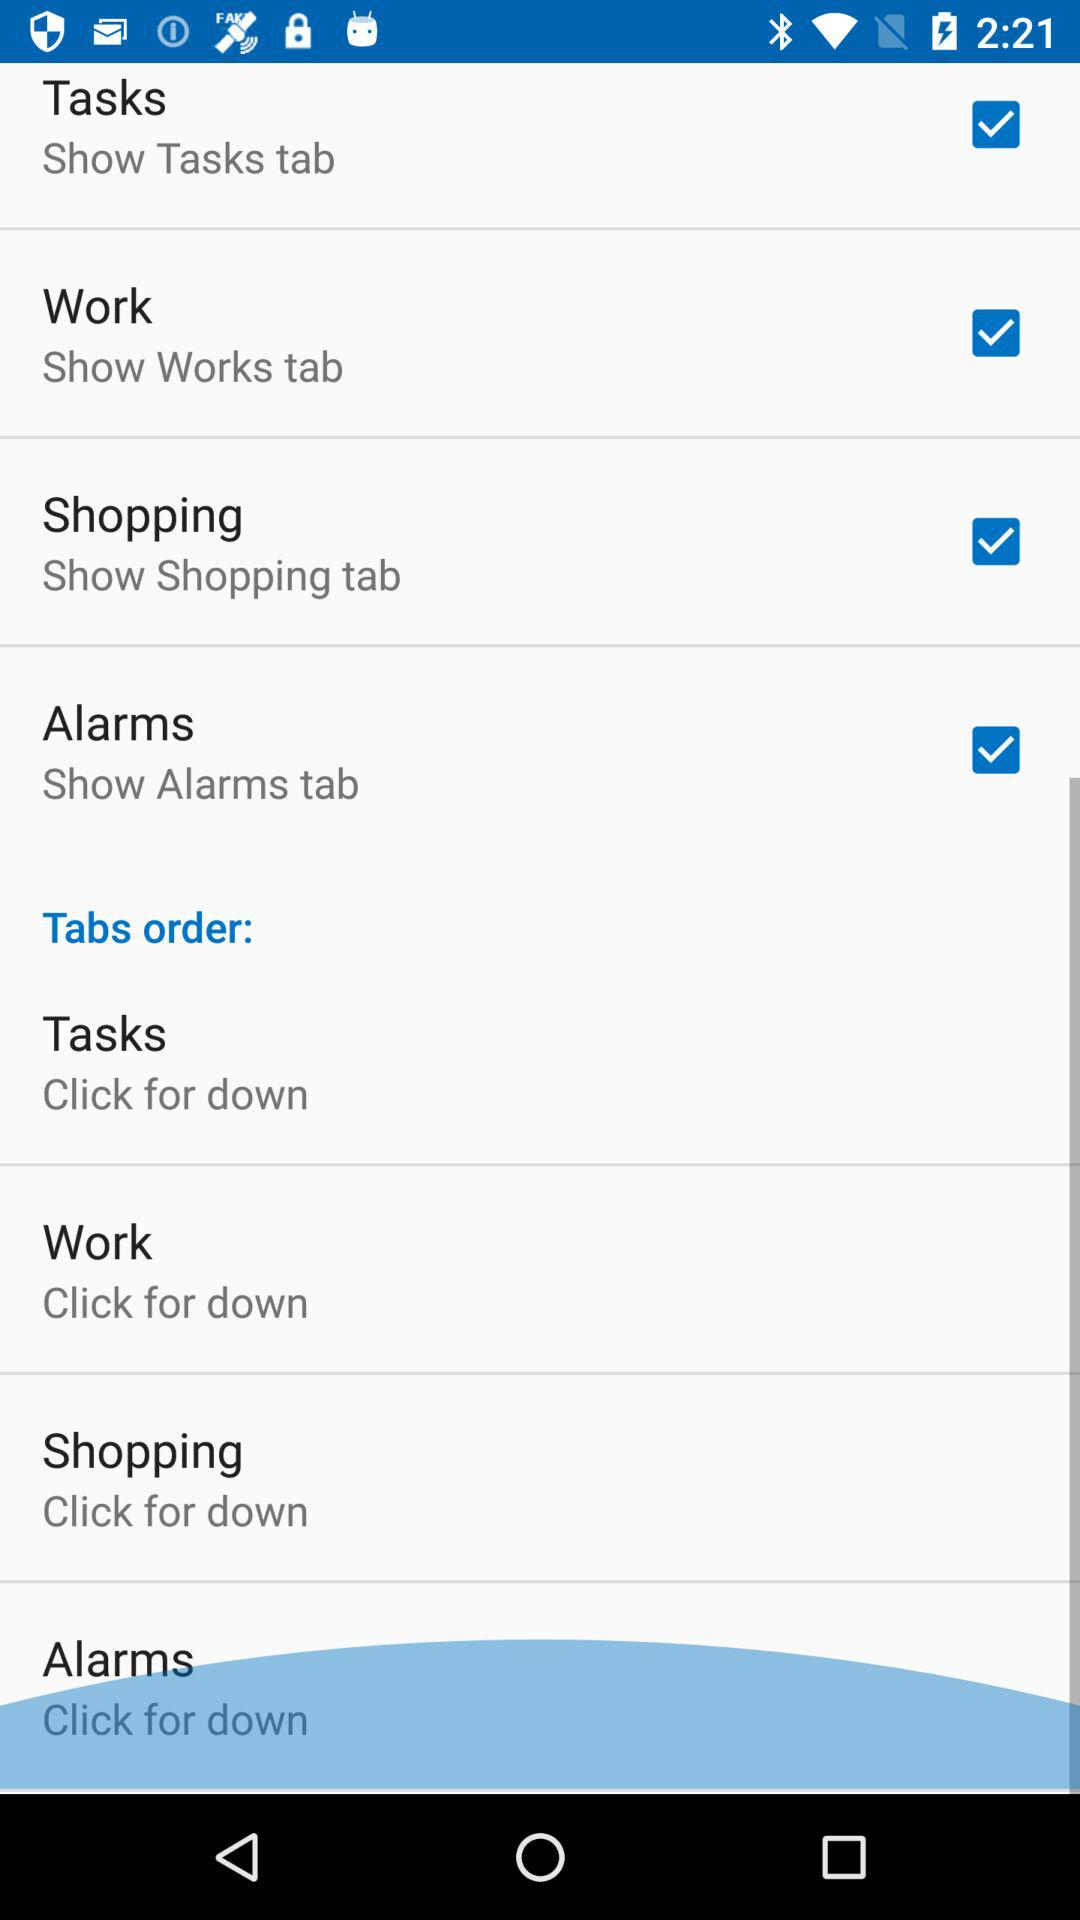What is the status of the "Tasks"? The status of the "Tasks" is "on". 